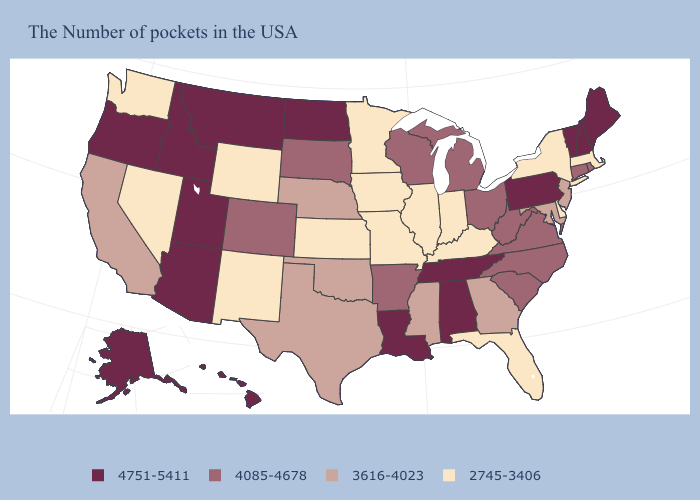Which states have the highest value in the USA?
Answer briefly. Maine, New Hampshire, Vermont, Pennsylvania, Alabama, Tennessee, Louisiana, North Dakota, Utah, Montana, Arizona, Idaho, Oregon, Alaska, Hawaii. What is the value of Nebraska?
Give a very brief answer. 3616-4023. Name the states that have a value in the range 2745-3406?
Be succinct. Massachusetts, New York, Delaware, Florida, Kentucky, Indiana, Illinois, Missouri, Minnesota, Iowa, Kansas, Wyoming, New Mexico, Nevada, Washington. Among the states that border Iowa , which have the lowest value?
Be succinct. Illinois, Missouri, Minnesota. Which states have the lowest value in the USA?
Quick response, please. Massachusetts, New York, Delaware, Florida, Kentucky, Indiana, Illinois, Missouri, Minnesota, Iowa, Kansas, Wyoming, New Mexico, Nevada, Washington. Does Ohio have a lower value than Vermont?
Short answer required. Yes. Does the map have missing data?
Quick response, please. No. Name the states that have a value in the range 2745-3406?
Answer briefly. Massachusetts, New York, Delaware, Florida, Kentucky, Indiana, Illinois, Missouri, Minnesota, Iowa, Kansas, Wyoming, New Mexico, Nevada, Washington. What is the value of Missouri?
Give a very brief answer. 2745-3406. Does Washington have the lowest value in the USA?
Give a very brief answer. Yes. Name the states that have a value in the range 4751-5411?
Answer briefly. Maine, New Hampshire, Vermont, Pennsylvania, Alabama, Tennessee, Louisiana, North Dakota, Utah, Montana, Arizona, Idaho, Oregon, Alaska, Hawaii. What is the value of Nevada?
Short answer required. 2745-3406. What is the highest value in the Northeast ?
Short answer required. 4751-5411. Name the states that have a value in the range 4085-4678?
Keep it brief. Rhode Island, Connecticut, Virginia, North Carolina, South Carolina, West Virginia, Ohio, Michigan, Wisconsin, Arkansas, South Dakota, Colorado. 